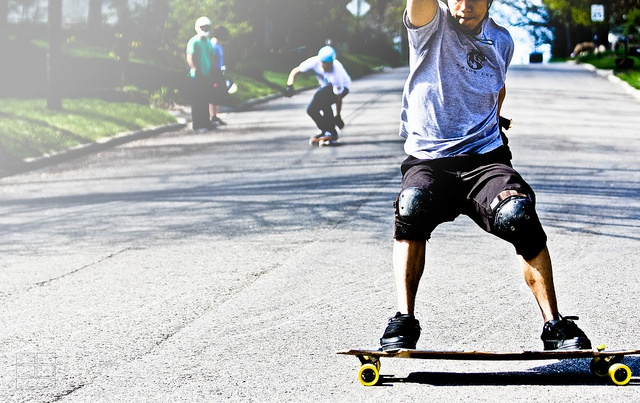Describe the objects in this image and their specific colors. I can see people in darkgray, black, white, and gray tones, skateboard in darkgray, black, white, gold, and maroon tones, people in darkgray, gray, lavender, and lightblue tones, people in darkgray, gray, white, and lightblue tones, and people in darkgray, gray, lightblue, and white tones in this image. 